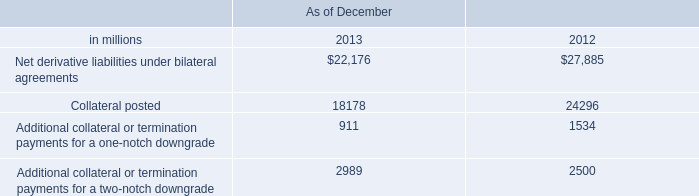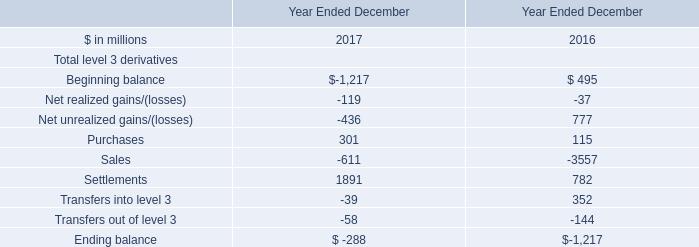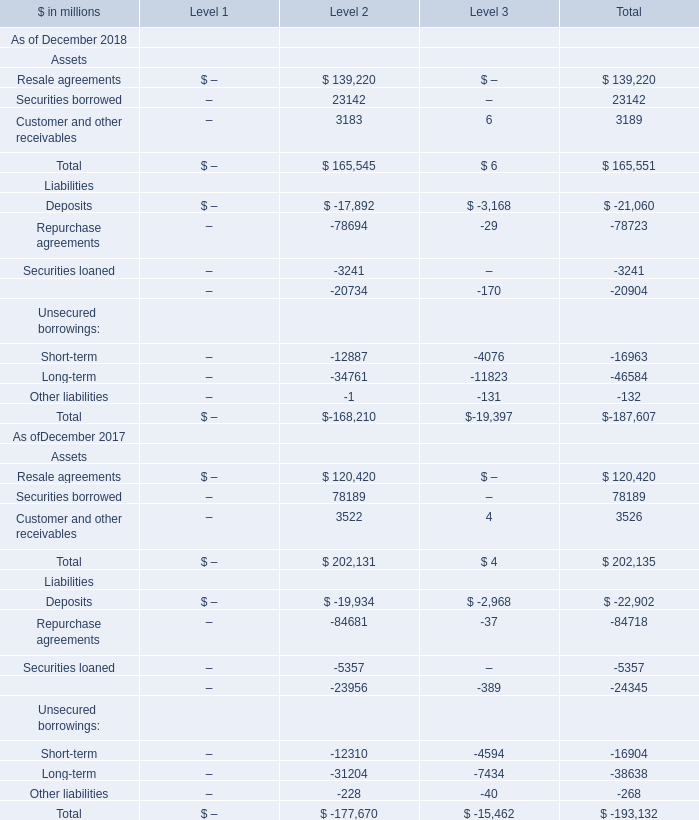Which Level is Total Assets the highest As of December 2018? 
Answer: 2. 